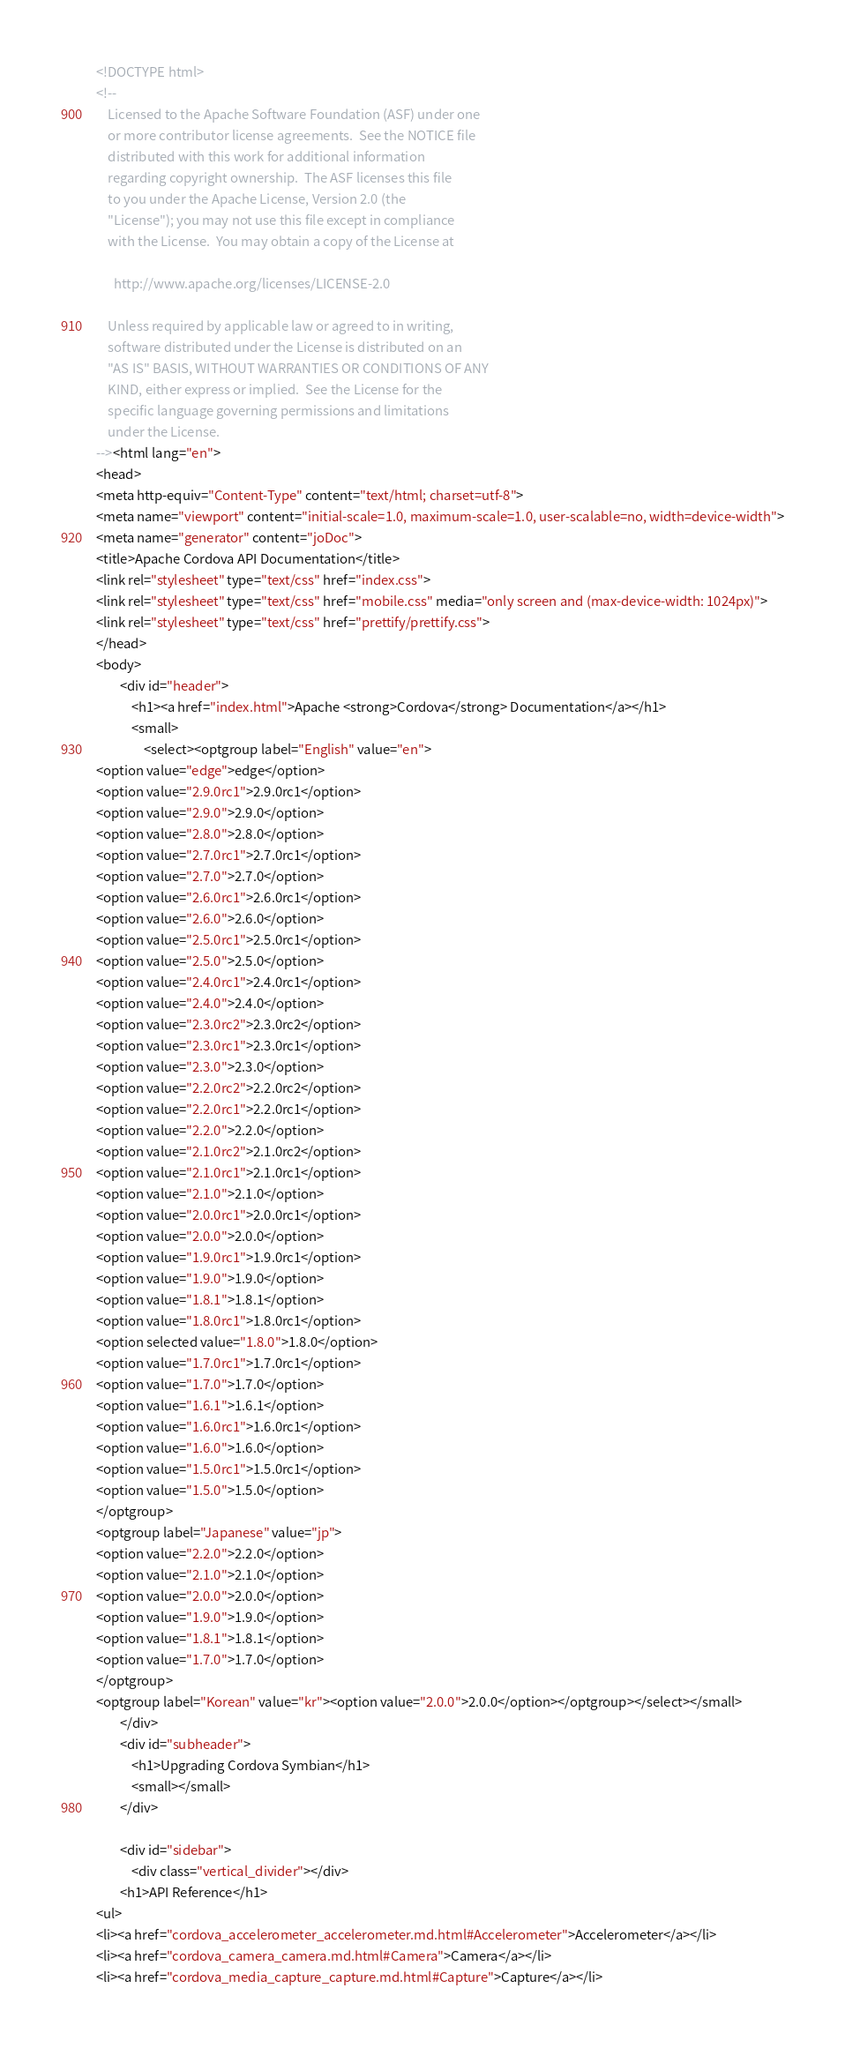Convert code to text. <code><loc_0><loc_0><loc_500><loc_500><_HTML_><!DOCTYPE html>
<!--
    Licensed to the Apache Software Foundation (ASF) under one
    or more contributor license agreements.  See the NOTICE file
    distributed with this work for additional information
    regarding copyright ownership.  The ASF licenses this file
    to you under the Apache License, Version 2.0 (the
    "License"); you may not use this file except in compliance
    with the License.  You may obtain a copy of the License at

      http://www.apache.org/licenses/LICENSE-2.0

    Unless required by applicable law or agreed to in writing,
    software distributed under the License is distributed on an
    "AS IS" BASIS, WITHOUT WARRANTIES OR CONDITIONS OF ANY
    KIND, either express or implied.  See the License for the
    specific language governing permissions and limitations
    under the License.
--><html lang="en">
<head>
<meta http-equiv="Content-Type" content="text/html; charset=utf-8">
<meta name="viewport" content="initial-scale=1.0, maximum-scale=1.0, user-scalable=no, width=device-width">
<meta name="generator" content="joDoc">
<title>Apache Cordova API Documentation</title>
<link rel="stylesheet" type="text/css" href="index.css">
<link rel="stylesheet" type="text/css" href="mobile.css" media="only screen and (max-device-width: 1024px)">
<link rel="stylesheet" type="text/css" href="prettify/prettify.css">
</head>
<body>
        <div id="header">
            <h1><a href="index.html">Apache <strong>Cordova</strong> Documentation</a></h1>
            <small>
                <select><optgroup label="English" value="en">
<option value="edge">edge</option>
<option value="2.9.0rc1">2.9.0rc1</option>
<option value="2.9.0">2.9.0</option>
<option value="2.8.0">2.8.0</option>
<option value="2.7.0rc1">2.7.0rc1</option>
<option value="2.7.0">2.7.0</option>
<option value="2.6.0rc1">2.6.0rc1</option>
<option value="2.6.0">2.6.0</option>
<option value="2.5.0rc1">2.5.0rc1</option>
<option value="2.5.0">2.5.0</option>
<option value="2.4.0rc1">2.4.0rc1</option>
<option value="2.4.0">2.4.0</option>
<option value="2.3.0rc2">2.3.0rc2</option>
<option value="2.3.0rc1">2.3.0rc1</option>
<option value="2.3.0">2.3.0</option>
<option value="2.2.0rc2">2.2.0rc2</option>
<option value="2.2.0rc1">2.2.0rc1</option>
<option value="2.2.0">2.2.0</option>
<option value="2.1.0rc2">2.1.0rc2</option>
<option value="2.1.0rc1">2.1.0rc1</option>
<option value="2.1.0">2.1.0</option>
<option value="2.0.0rc1">2.0.0rc1</option>
<option value="2.0.0">2.0.0</option>
<option value="1.9.0rc1">1.9.0rc1</option>
<option value="1.9.0">1.9.0</option>
<option value="1.8.1">1.8.1</option>
<option value="1.8.0rc1">1.8.0rc1</option>
<option selected value="1.8.0">1.8.0</option>
<option value="1.7.0rc1">1.7.0rc1</option>
<option value="1.7.0">1.7.0</option>
<option value="1.6.1">1.6.1</option>
<option value="1.6.0rc1">1.6.0rc1</option>
<option value="1.6.0">1.6.0</option>
<option value="1.5.0rc1">1.5.0rc1</option>
<option value="1.5.0">1.5.0</option>
</optgroup>
<optgroup label="Japanese" value="jp">
<option value="2.2.0">2.2.0</option>
<option value="2.1.0">2.1.0</option>
<option value="2.0.0">2.0.0</option>
<option value="1.9.0">1.9.0</option>
<option value="1.8.1">1.8.1</option>
<option value="1.7.0">1.7.0</option>
</optgroup>
<optgroup label="Korean" value="kr"><option value="2.0.0">2.0.0</option></optgroup></select></small>
        </div>
        <div id="subheader">
            <h1>Upgrading Cordova Symbian</h1>
            <small></small>
        </div>

        <div id="sidebar">
            <div class="vertical_divider"></div>
        <h1>API Reference</h1>
<ul>
<li><a href="cordova_accelerometer_accelerometer.md.html#Accelerometer">Accelerometer</a></li>
<li><a href="cordova_camera_camera.md.html#Camera">Camera</a></li>
<li><a href="cordova_media_capture_capture.md.html#Capture">Capture</a></li></code> 